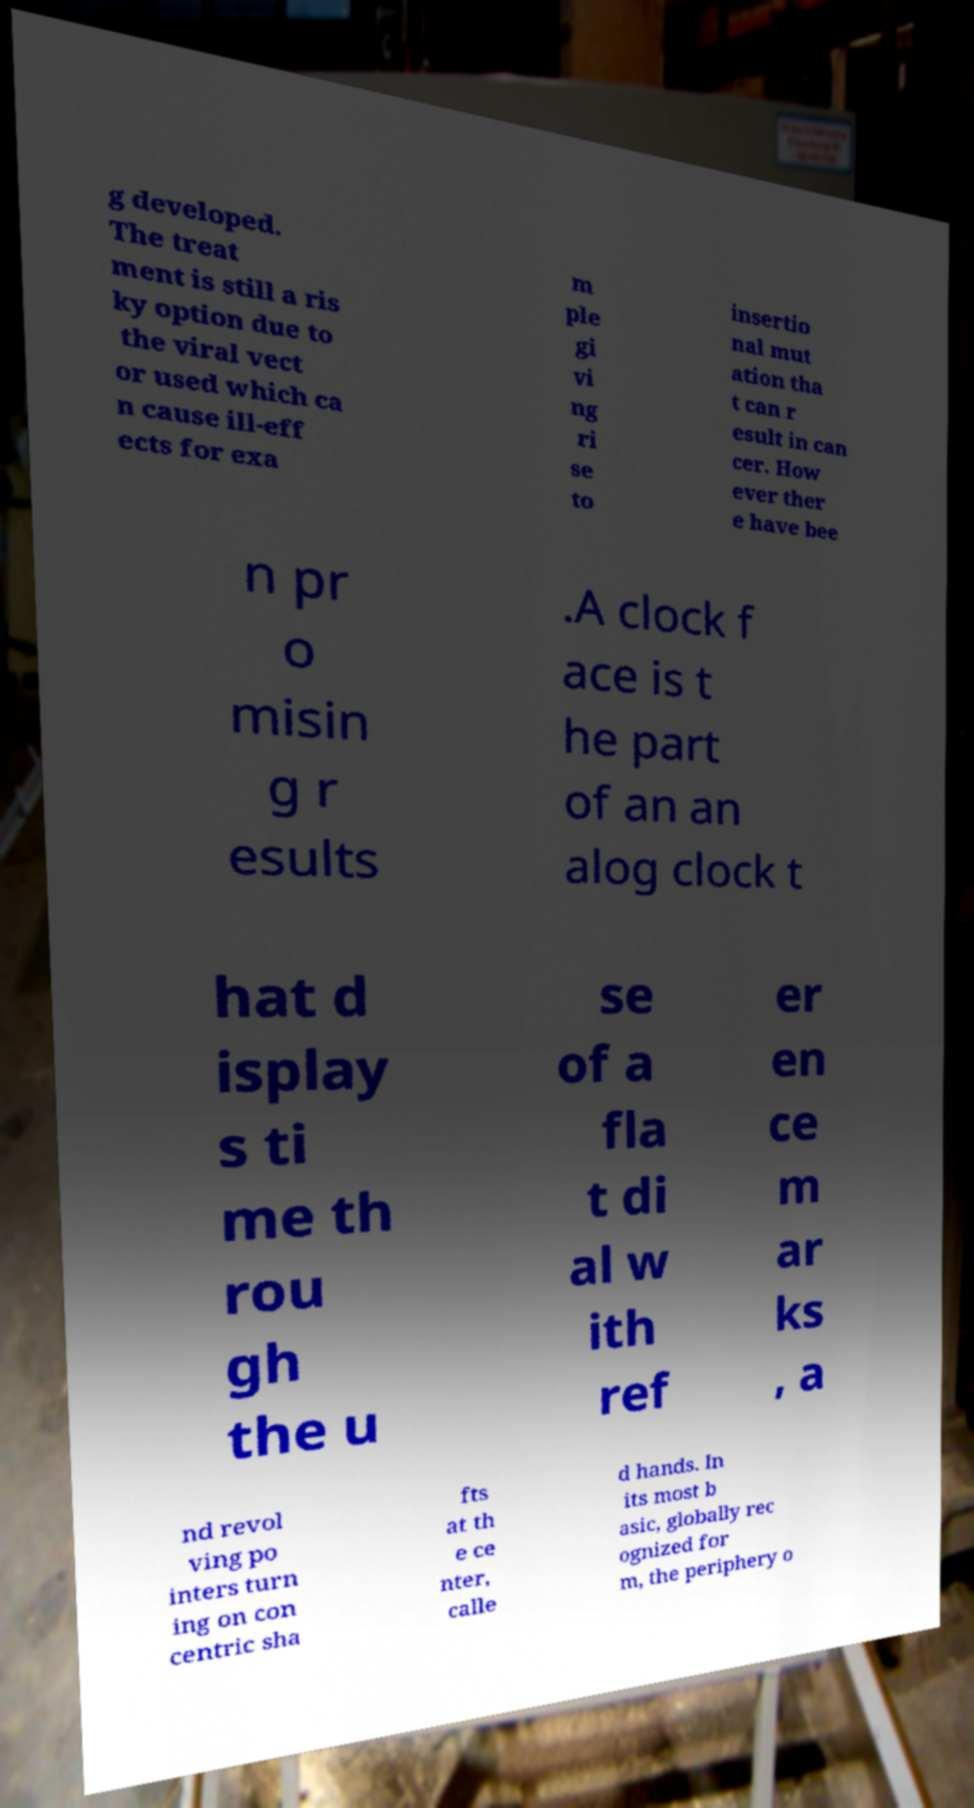Can you read and provide the text displayed in the image?This photo seems to have some interesting text. Can you extract and type it out for me? g developed. The treat ment is still a ris ky option due to the viral vect or used which ca n cause ill-eff ects for exa m ple gi vi ng ri se to insertio nal mut ation tha t can r esult in can cer. How ever ther e have bee n pr o misin g r esults .A clock f ace is t he part of an an alog clock t hat d isplay s ti me th rou gh the u se of a fla t di al w ith ref er en ce m ar ks , a nd revol ving po inters turn ing on con centric sha fts at th e ce nter, calle d hands. In its most b asic, globally rec ognized for m, the periphery o 